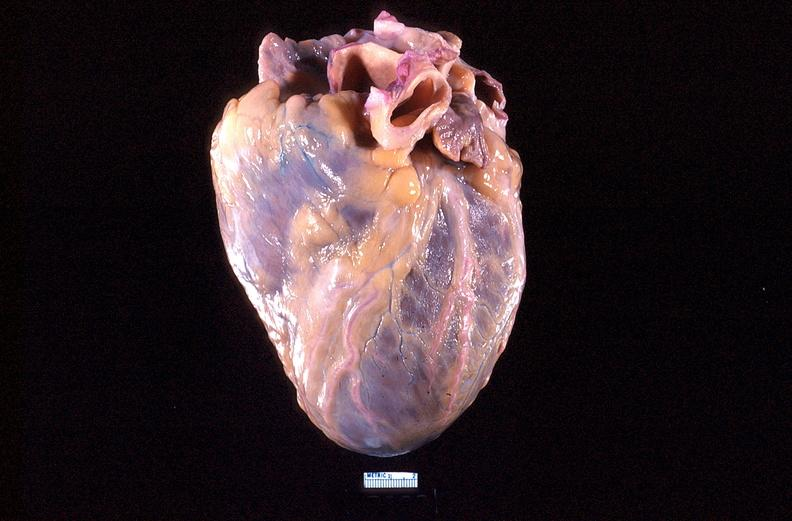does retroperitoneum show heart, anterior surface, acute posterior myocardial infarction?
Answer the question using a single word or phrase. No 